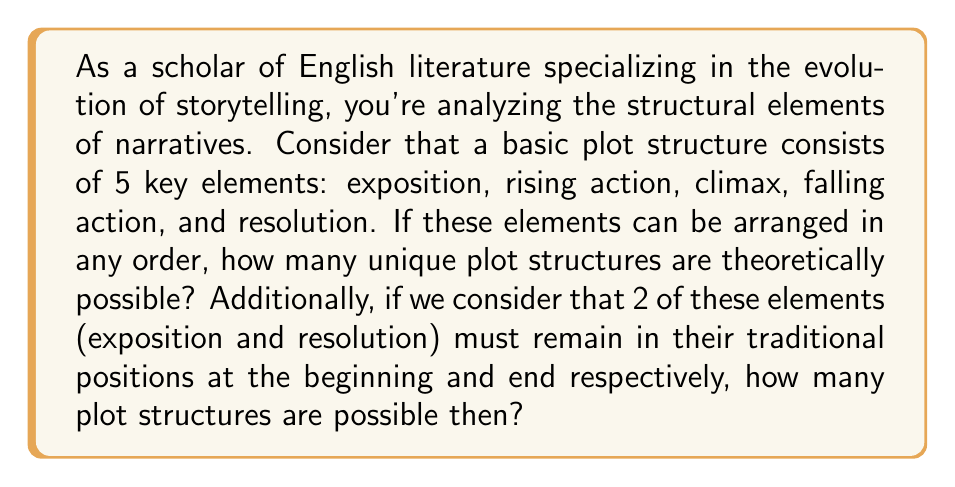Teach me how to tackle this problem. Let's approach this problem step-by-step:

1) For the first part of the question, we need to calculate the number of ways to arrange 5 distinct elements. This is a straightforward permutation:

   $$P(5,5) = 5! = 5 \times 4 \times 3 \times 2 \times 1 = 120$$

2) For the second part, we have 2 fixed elements (exposition at the beginning and resolution at the end) and 3 elements that can be arranged in any order between them.

3) This is equivalent to arranging 3 elements, which is:

   $$P(3,3) = 3! = 3 \times 2 \times 1 = 6$$

Therefore, there are 120 possible plot structures when all elements can be rearranged, and 6 possible structures when exposition and resolution are fixed.
Answer: 120 and 6 